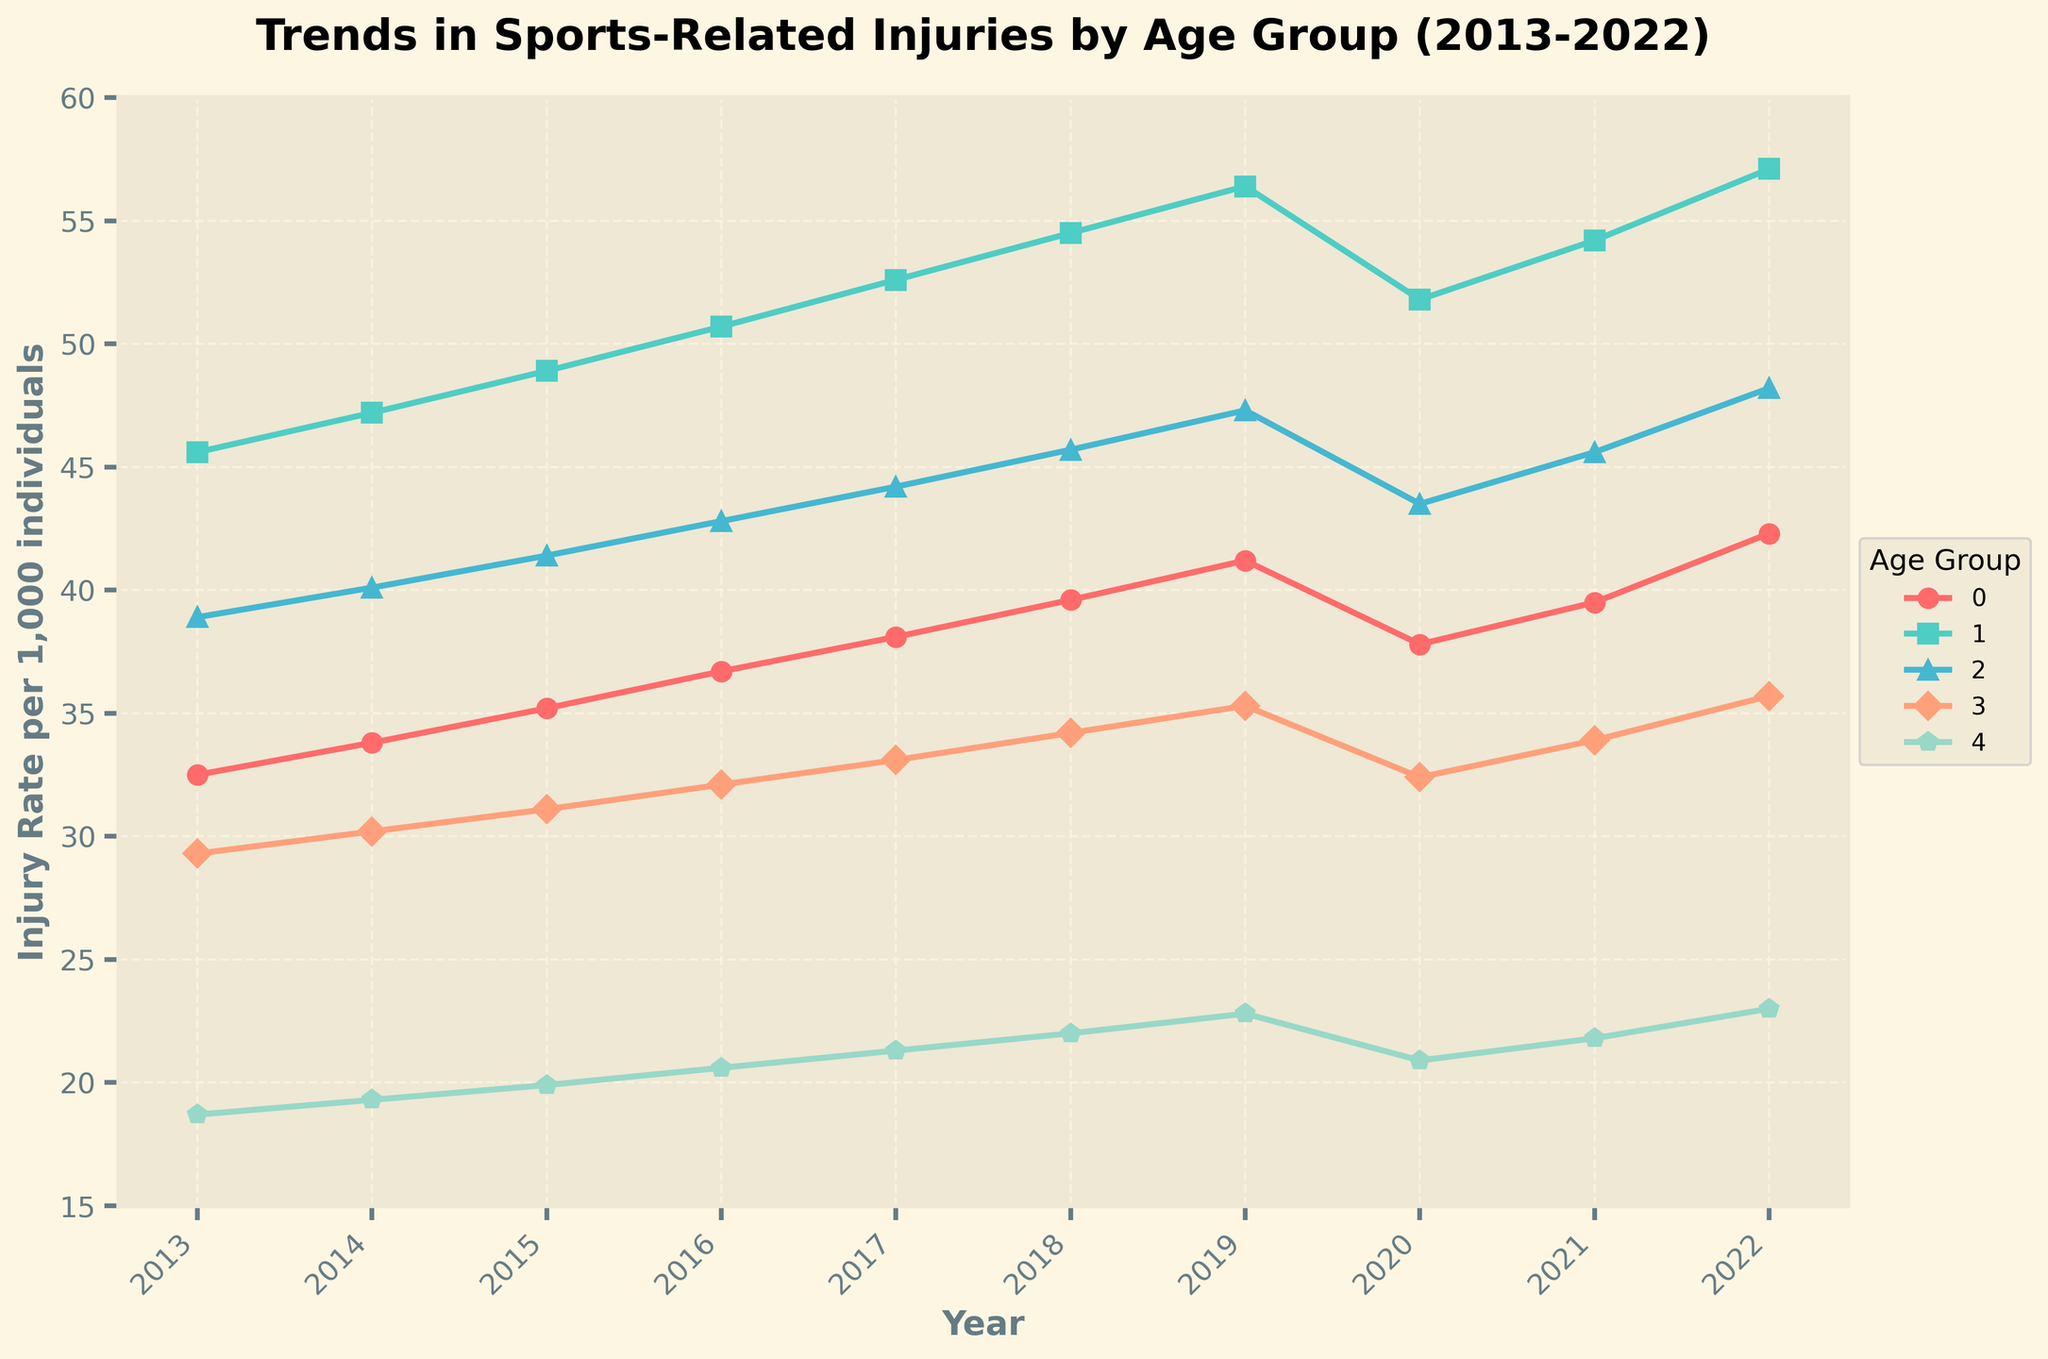What is the general trend in sports-related injuries for Teenagers (13-19) over the past decade? The blue line representing Teenagers (13-19) shows an overall increasing trend. Starting from 45.6 in 2013, it reaches 57.1 by 2022. While there is a slight dip in 2020, the trend picks up again in the subsequent years. This indicates a general upward trend over the decade.
Answer: Increasing Which age group experienced the highest injury rate in 2022? Looking at the end of each line, the red line for Teenagers (13-19) is the highest in 2022 with a value of 57.1. This is higher than any other age group in that year.
Answer: Teenagers (13-19) How did the injury rate for Children (5-12) change from 2020 to 2022? In 2020, the injury rate for Children (5-12) was 37.8. By 2022, it increased to 42.3. To determine the change: 42.3 - 37.8 = 4.5. Thus, the injury rate increased by 4.5.
Answer: Increased by 4.5 Which age group consistently had the lowest injury rate throughout the decade? Observing the trends, the purple line for Older Adults (55+) consistently remains the lowest throughout the timeline. It starts at 18.7 in 2013 and ends at 23.0 in 2022, which is lower compared to other age group trends.
Answer: Older Adults (55+) What can you infer about the injury rates for Young Adults (20-34) and Adults (35-54) between 2018 and 2022? Between 2018 and 2022, the injury rate for Young Adults (20-34) increases from 45.7 to 48.2, while for Adults (35-54), it goes from 34.2 to 35.7. Both age groups show an upward trend but at different magnitudes.
Answer: Both increased Which two age groups showed a decrease in injury rate between any two consecutive years within the data provided? Analyzing the lines, 
- Children (5-12): Decreases from 41.2 in 2019 to 37.8 in 2020
- Teenagers (13-19): Decreases from 56.4 in 2019 to 51.8 in 2020
Answer: Children (5-12) and Teenagers (13-19) What was the average injury rate for Adults (35-54) over the decade? Sum the values: 29.3 + 30.2 + 31.1 + 32.1 + 33.1 + 34.2 + 35.3 + 32.4 + 33.9 + 35.7 = 327.3. Number of years = 10. Average = 327.3 / 10 = 32.73.
Answer: 32.73 How does the injury rate for Teenagers (13-19) in 2014 compare to that for Older Adults (55+) in 2022? For Teenagers (13-19) in 2014, the rate is 47.2. For Older Adults (55+) in 2022, the rate is 23.0. Since 47.2 is greater than 23.0, Teenagers (13-19) in 2014 had a higher injury rate.
Answer: Teenagers (13-19) higher in 2014 